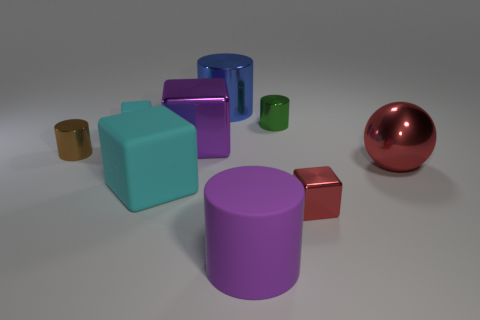The tiny thing that is both on the right side of the tiny brown metal object and left of the large purple shiny object has what shape?
Your answer should be compact. Cube. How many big purple matte objects have the same shape as the small matte thing?
Ensure brevity in your answer.  0. There is a purple object that is made of the same material as the large red thing; what is its size?
Provide a short and direct response. Large. What number of cyan objects are the same size as the green cylinder?
Provide a succinct answer. 1. What is the size of the other object that is the same color as the tiny rubber thing?
Make the answer very short. Large. The tiny metal object to the left of the big object behind the tiny cyan rubber block is what color?
Your response must be concise. Brown. Are there any big objects that have the same color as the rubber cylinder?
Give a very brief answer. Yes. There is a metallic block that is the same size as the blue cylinder; what is its color?
Offer a terse response. Purple. Is the material of the thing that is left of the small matte object the same as the big red object?
Your answer should be compact. Yes. There is a matte block that is to the right of the small cube that is on the left side of the rubber cylinder; are there any purple cubes that are behind it?
Ensure brevity in your answer.  Yes. 